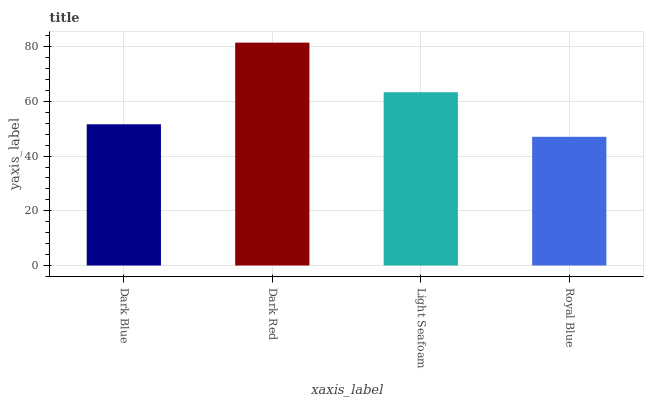Is Royal Blue the minimum?
Answer yes or no. Yes. Is Dark Red the maximum?
Answer yes or no. Yes. Is Light Seafoam the minimum?
Answer yes or no. No. Is Light Seafoam the maximum?
Answer yes or no. No. Is Dark Red greater than Light Seafoam?
Answer yes or no. Yes. Is Light Seafoam less than Dark Red?
Answer yes or no. Yes. Is Light Seafoam greater than Dark Red?
Answer yes or no. No. Is Dark Red less than Light Seafoam?
Answer yes or no. No. Is Light Seafoam the high median?
Answer yes or no. Yes. Is Dark Blue the low median?
Answer yes or no. Yes. Is Royal Blue the high median?
Answer yes or no. No. Is Dark Red the low median?
Answer yes or no. No. 